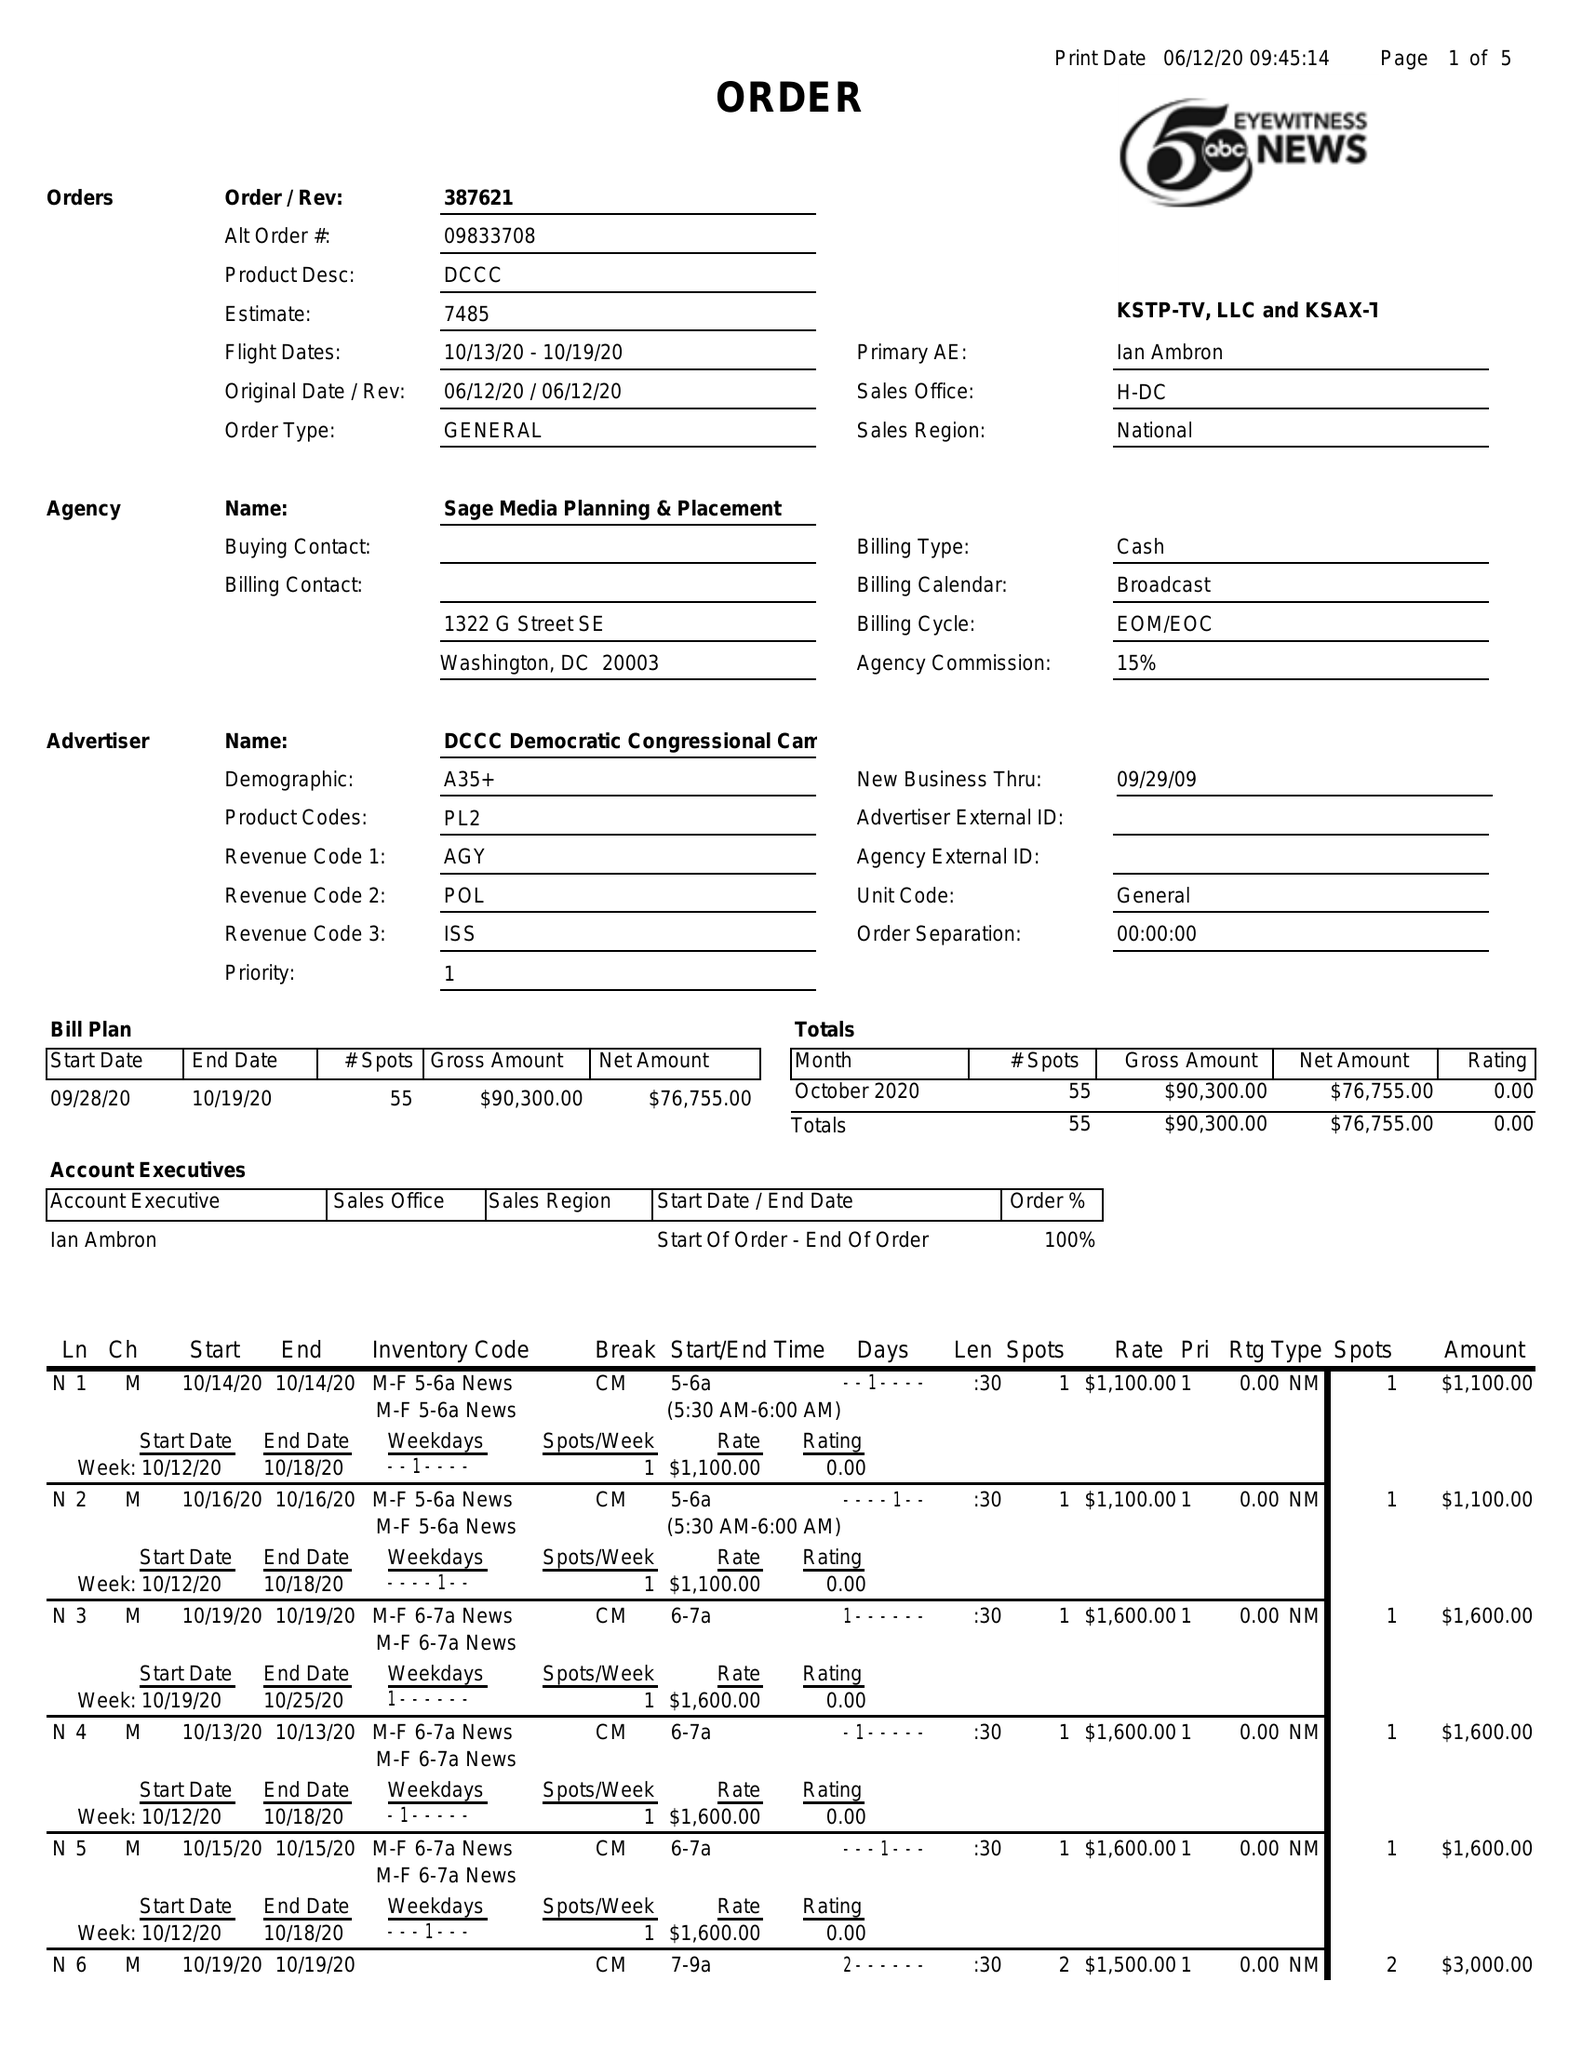What is the value for the flight_to?
Answer the question using a single word or phrase. 10/19/20 